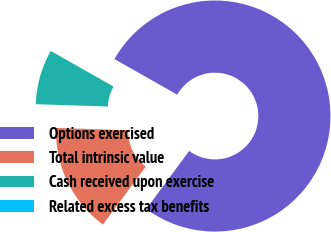<chart> <loc_0><loc_0><loc_500><loc_500><pie_chart><fcel>Options exercised<fcel>Total intrinsic value<fcel>Cash received upon exercise<fcel>Related excess tax benefits<nl><fcel>76.92%<fcel>15.39%<fcel>7.69%<fcel>0.0%<nl></chart> 